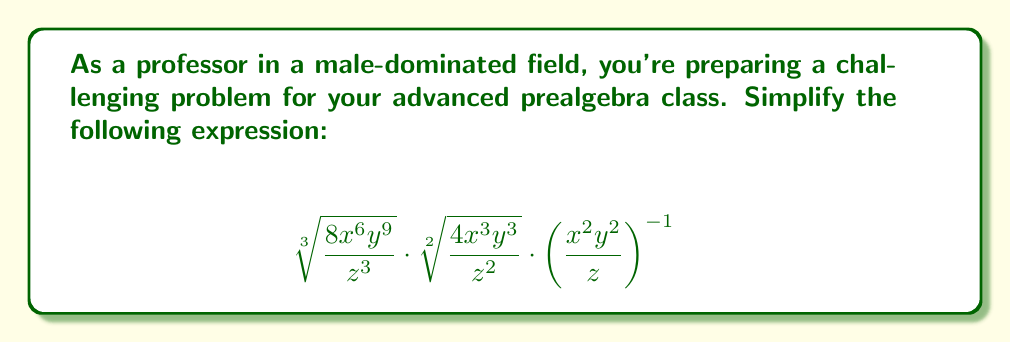Show me your answer to this math problem. Let's approach this step-by-step:

1) First, let's simplify the cube root:
   $$\sqrt[3]{\frac{8x^6y^9}{z^3}} = \frac{2x^2y^3}{z}$$

2) Next, simplify the square root:
   $$\sqrt[2]{\frac{4x^3y^3}{z^2}} = \frac{2xy^{\frac{3}{2}}}{z}$$

3) For the last term, recall that a negative exponent means reciprocal:
   $$\left(\frac{x^2y^2}{z}\right)^{-1} = \frac{z}{x^2y^2}$$

4) Now, multiply these three terms:
   $$\frac{2x^2y^3}{z} \cdot \frac{2xy^{\frac{3}{2}}}{z} \cdot \frac{z}{x^2y^2}$$

5) Multiply the numerators and denominators:
   $$\frac{4x^3y^3 \cdot y^{\frac{3}{2}}}{z^2}$$

6) Simplify the y terms:
   $$\frac{4x^3y^{\frac{9}{2}}}{z^2}$$

This is our simplified expression.
Answer: $$\frac{4x^3y^{\frac{9}{2}}}{z^2}$$ 